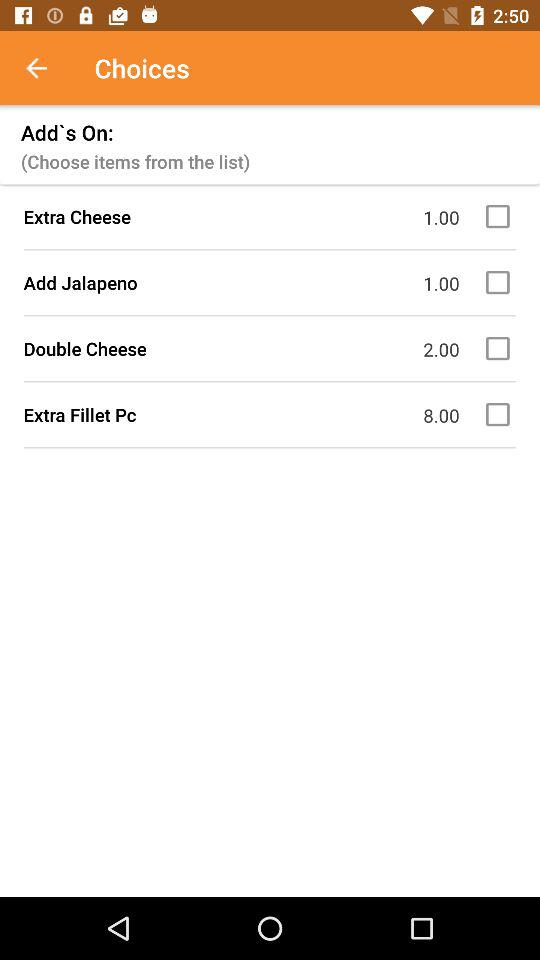Which options are given as add-ons? The given options are "Extra Cheese", "Add Jalapeno", "Double Cheese" and "Extra Fillet Pc". 